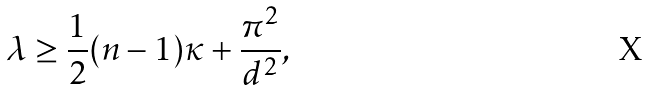Convert formula to latex. <formula><loc_0><loc_0><loc_500><loc_500>\lambda \geq \frac { 1 } { 2 } ( n - 1 ) \kappa + \frac { \pi ^ { 2 } } { d ^ { 2 } } ,</formula> 